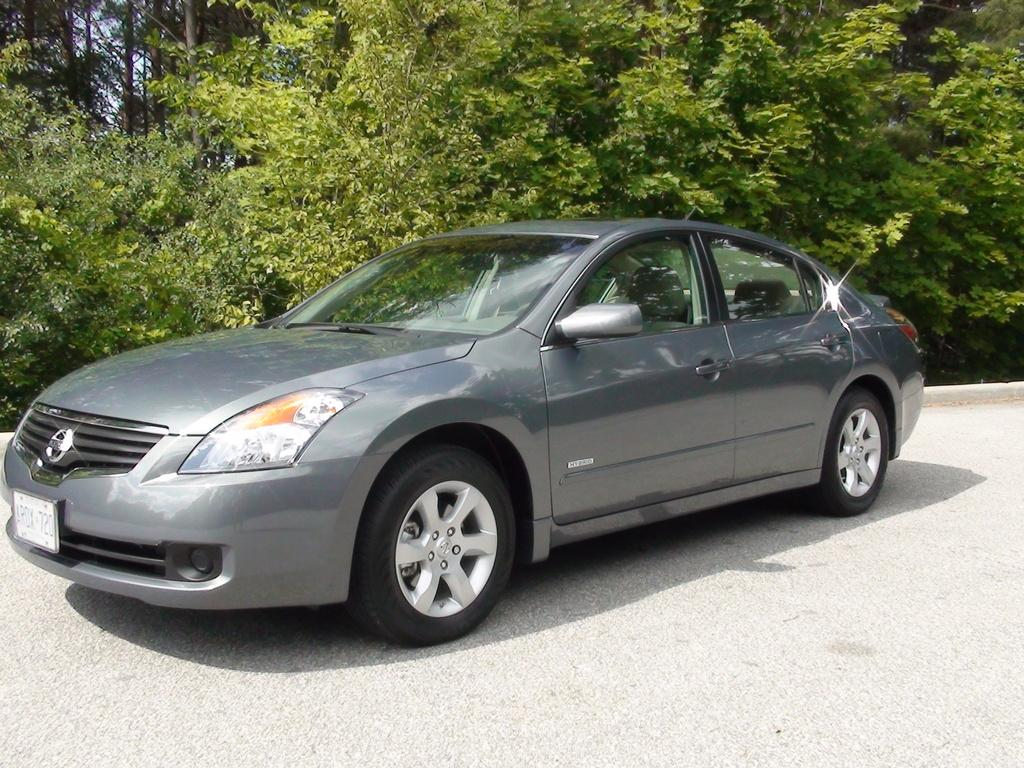<image>
Share a concise interpretation of the image provided. A gray car has a license plate number of ARDX-720. 